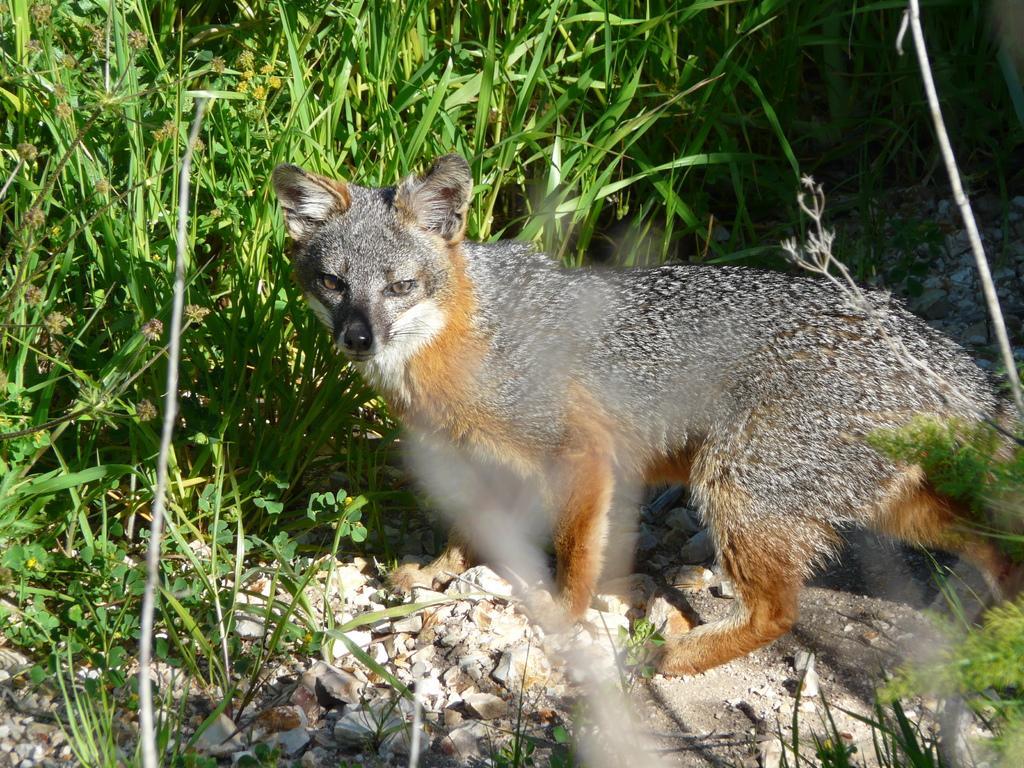In one or two sentences, can you explain what this image depicts? The picture consists of stones, plants, grass and an animal. 